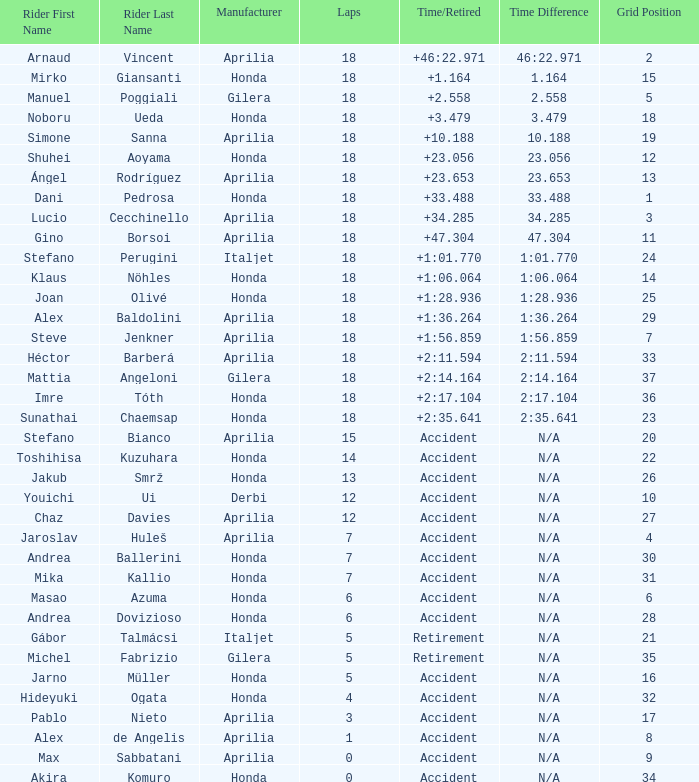What is the time/retired of the honda manufacturer with a grid less than 26, 18 laps, and joan olivé as the rider? +1:28.936. 